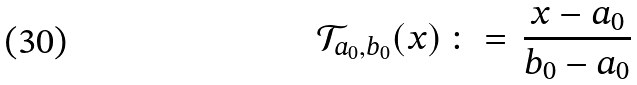Convert formula to latex. <formula><loc_0><loc_0><loc_500><loc_500>\mathcal { T } _ { a _ { 0 } , b _ { 0 } } ( x ) \, \colon = \, \frac { x - a _ { 0 } } { b _ { 0 } - a _ { 0 } }</formula> 